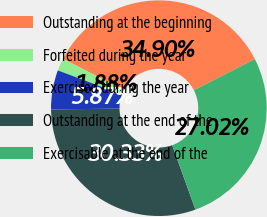Convert chart. <chart><loc_0><loc_0><loc_500><loc_500><pie_chart><fcel>Outstanding at the beginning<fcel>Forfeited during the year<fcel>Exercised during the year<fcel>Outstanding at the end of the<fcel>Exercisable at the end of the<nl><fcel>34.9%<fcel>1.88%<fcel>5.87%<fcel>30.33%<fcel>27.02%<nl></chart> 